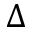Convert formula to latex. <formula><loc_0><loc_0><loc_500><loc_500>\Delta</formula> 